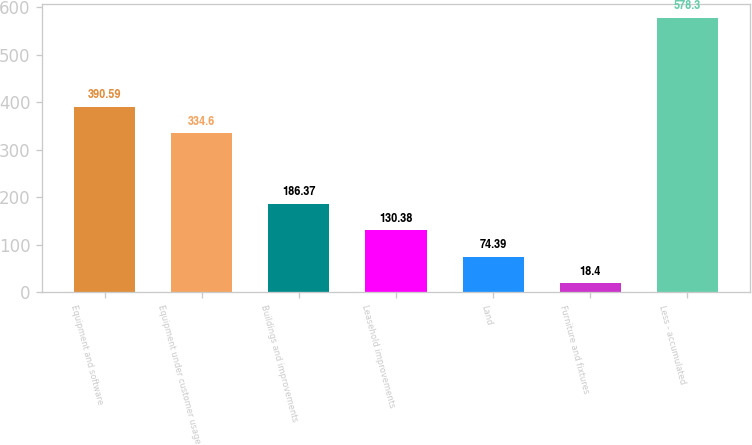Convert chart to OTSL. <chart><loc_0><loc_0><loc_500><loc_500><bar_chart><fcel>Equipment and software<fcel>Equipment under customer usage<fcel>Buildings and improvements<fcel>Leasehold improvements<fcel>Land<fcel>Furniture and fixtures<fcel>Less - accumulated<nl><fcel>390.59<fcel>334.6<fcel>186.37<fcel>130.38<fcel>74.39<fcel>18.4<fcel>578.3<nl></chart> 